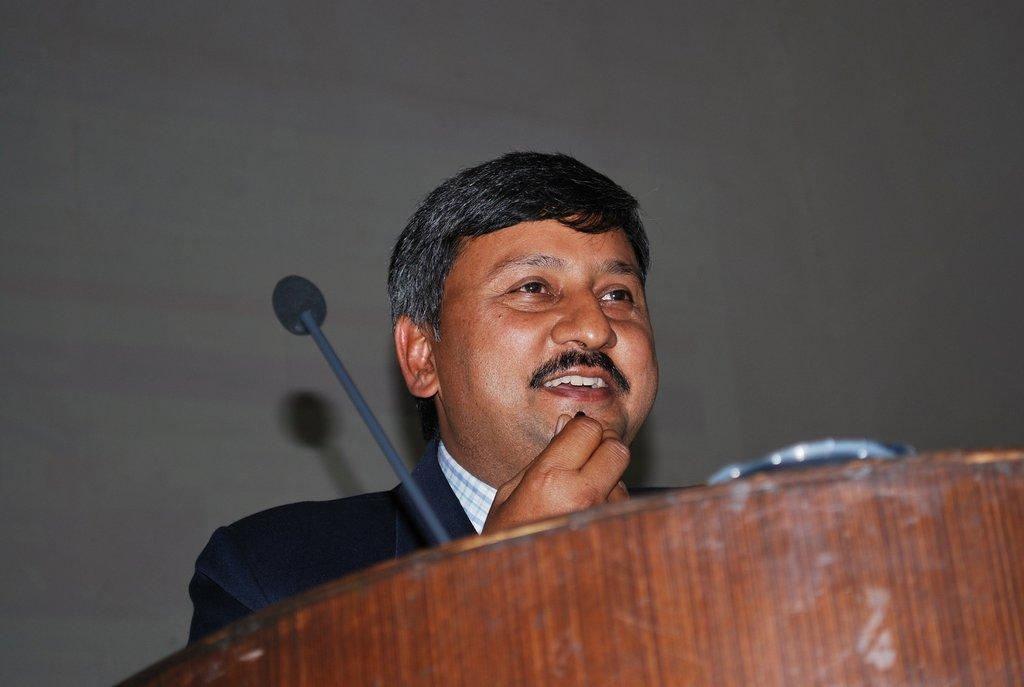Who is present in the image? There is a person in the image. What is the person doing in the image? The person is standing and smiling. What objects are present in the image besides the person? There is a podium and a microphone (mic) in the image. What type of flag is being waved by the person in the image? There is no flag present in the image. How does the person's heart rate appear to be affected by their actions in the image? There is no information about the person's heart rate in the image. 